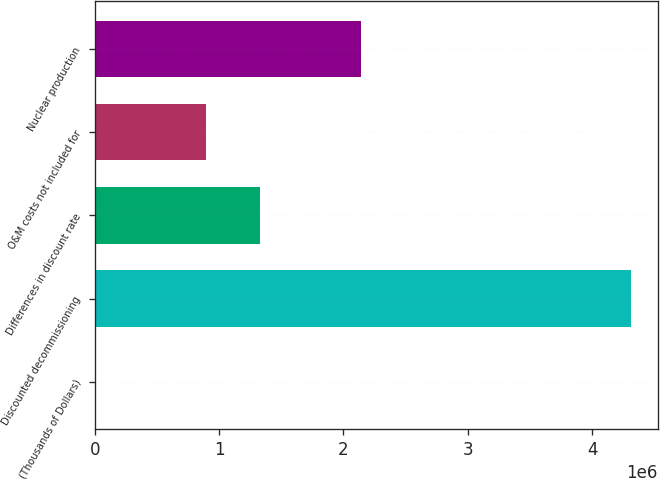Convert chart to OTSL. <chart><loc_0><loc_0><loc_500><loc_500><bar_chart><fcel>(Thousands of Dollars)<fcel>Discounted decommissioning<fcel>Differences in discount rate<fcel>O&M costs not included for<fcel>Nuclear production<nl><fcel>2015<fcel>4.3141e+06<fcel>1.32885e+06<fcel>897640<fcel>2.14102e+06<nl></chart> 